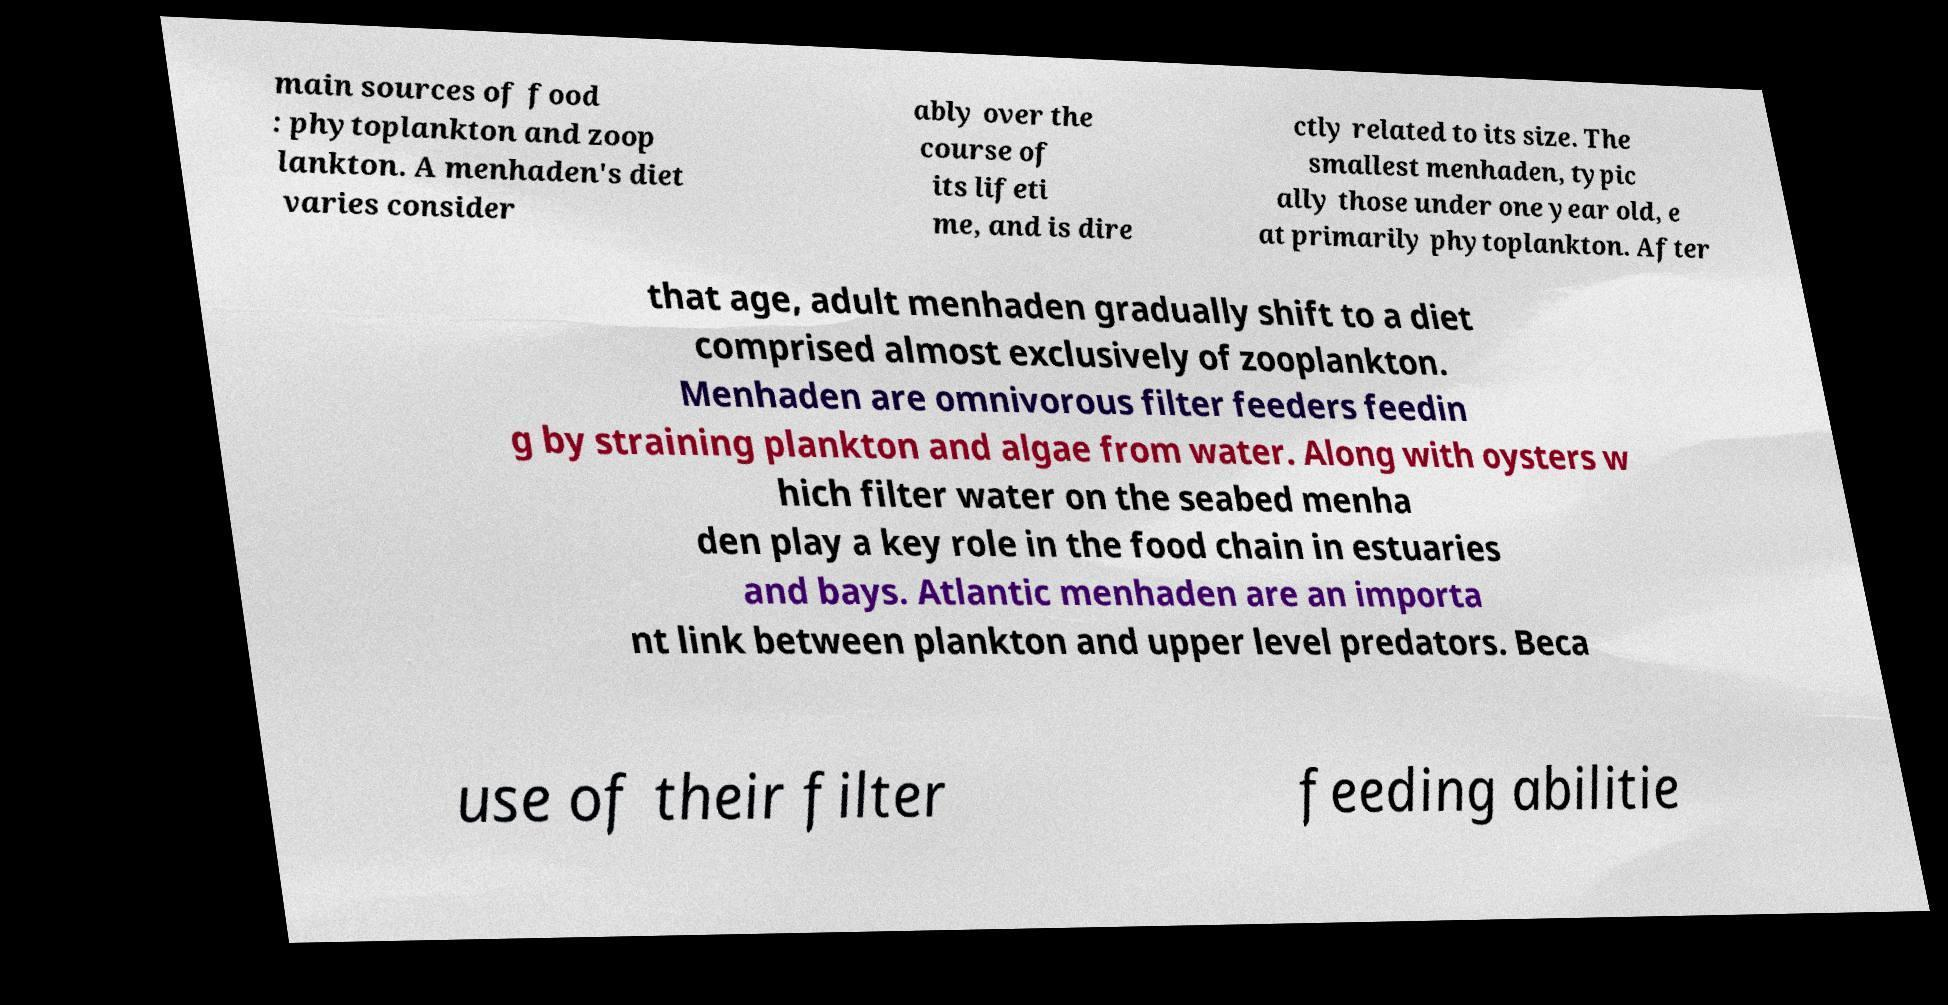Could you assist in decoding the text presented in this image and type it out clearly? main sources of food : phytoplankton and zoop lankton. A menhaden's diet varies consider ably over the course of its lifeti me, and is dire ctly related to its size. The smallest menhaden, typic ally those under one year old, e at primarily phytoplankton. After that age, adult menhaden gradually shift to a diet comprised almost exclusively of zooplankton. Menhaden are omnivorous filter feeders feedin g by straining plankton and algae from water. Along with oysters w hich filter water on the seabed menha den play a key role in the food chain in estuaries and bays. Atlantic menhaden are an importa nt link between plankton and upper level predators. Beca use of their filter feeding abilitie 